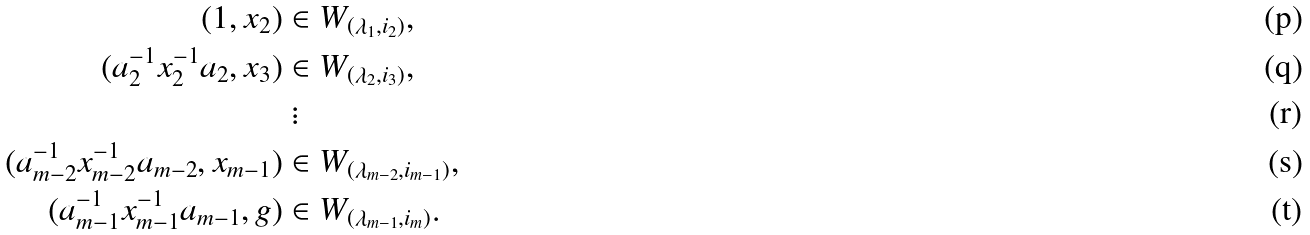<formula> <loc_0><loc_0><loc_500><loc_500>( 1 , x _ { 2 } ) & \in W _ { ( \lambda _ { 1 } , i _ { 2 } ) } , \\ ( a _ { 2 } ^ { - 1 } x _ { 2 } ^ { - 1 } a _ { 2 } , x _ { 3 } ) & \in W _ { ( \lambda _ { 2 } , i _ { 3 } ) } , \\ & \ \vdots \\ ( a _ { m - 2 } ^ { - 1 } x _ { m - 2 } ^ { - 1 } a _ { m - 2 } , x _ { m - 1 } ) & \in W _ { ( \lambda _ { m - 2 } , i _ { m - 1 } ) } , \\ ( a _ { m - 1 } ^ { - 1 } x _ { m - 1 } ^ { - 1 } a _ { m - 1 } , g ) & \in W _ { ( \lambda _ { m - 1 } , i _ { m } ) } .</formula> 